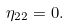Convert formula to latex. <formula><loc_0><loc_0><loc_500><loc_500>\eta _ { 2 2 } = 0 .</formula> 